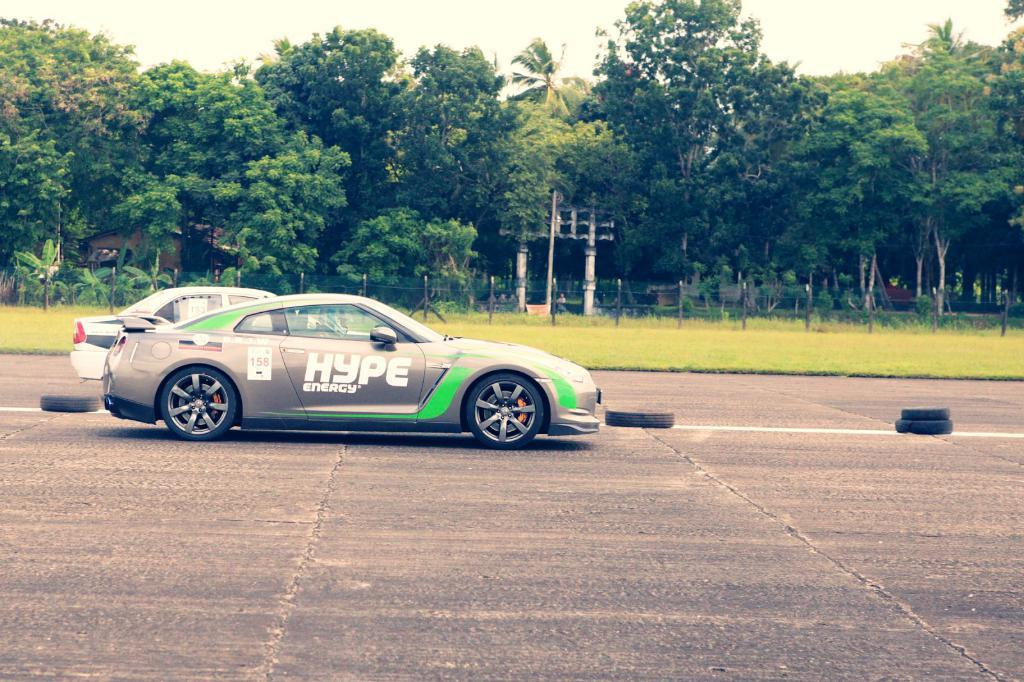What type of vehicles can be seen in the image? There are cars in the image. What objects related to the cars are placed on the road? There are tires placed on the road in the image. What type of vegetation is visible in the image? There is grass visible in the image. What structures can be seen in the image? There is a fence, a pole, and a tomb in the image. What type of natural formation is present in the image? There is a group of trees in the image. What part of the natural environment is visible in the image? The sky is visible in the image. How does the sky appear in the image? The sky appears cloudy in the image. What flavor of station can be seen in the image? There is no station present in the image, and therefore no flavor can be determined. What type of jar is visible in the image? There is no jar present in the image. 